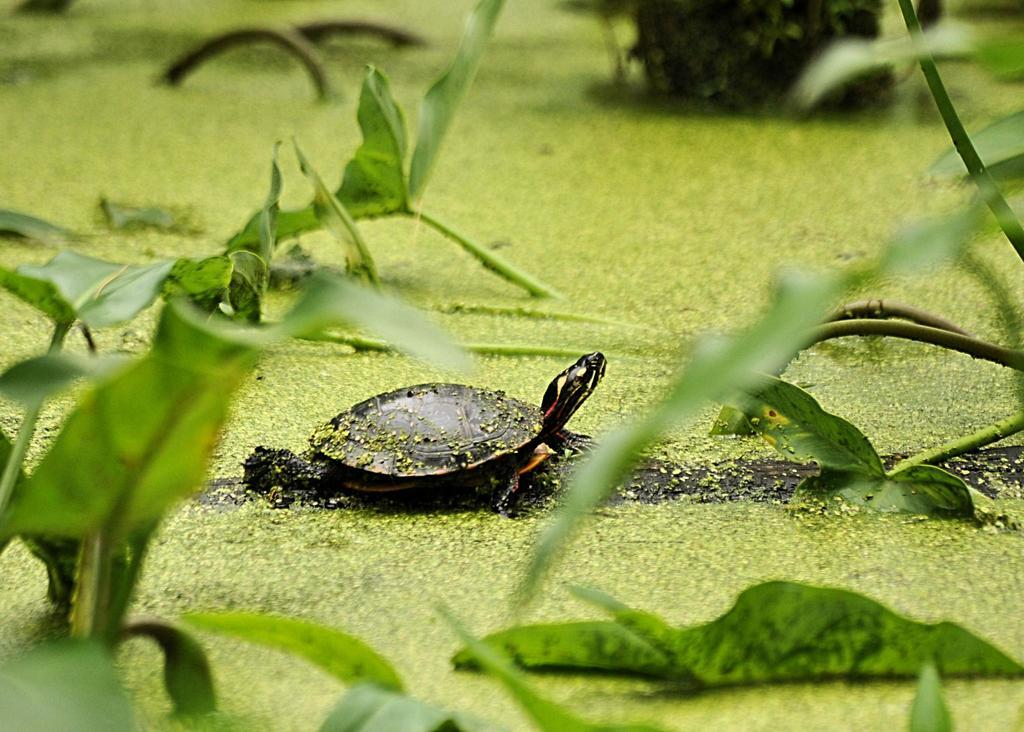What celestial bodies are depicted in the image? There are planets in the image. What animal can be seen on the ground in the image? There is a turtle on the ground in the image. What type of cherry is being used as a decoration on the turtle's shell in the image? There is no cherry present in the image, and the turtle's shell does not have any decorations. 